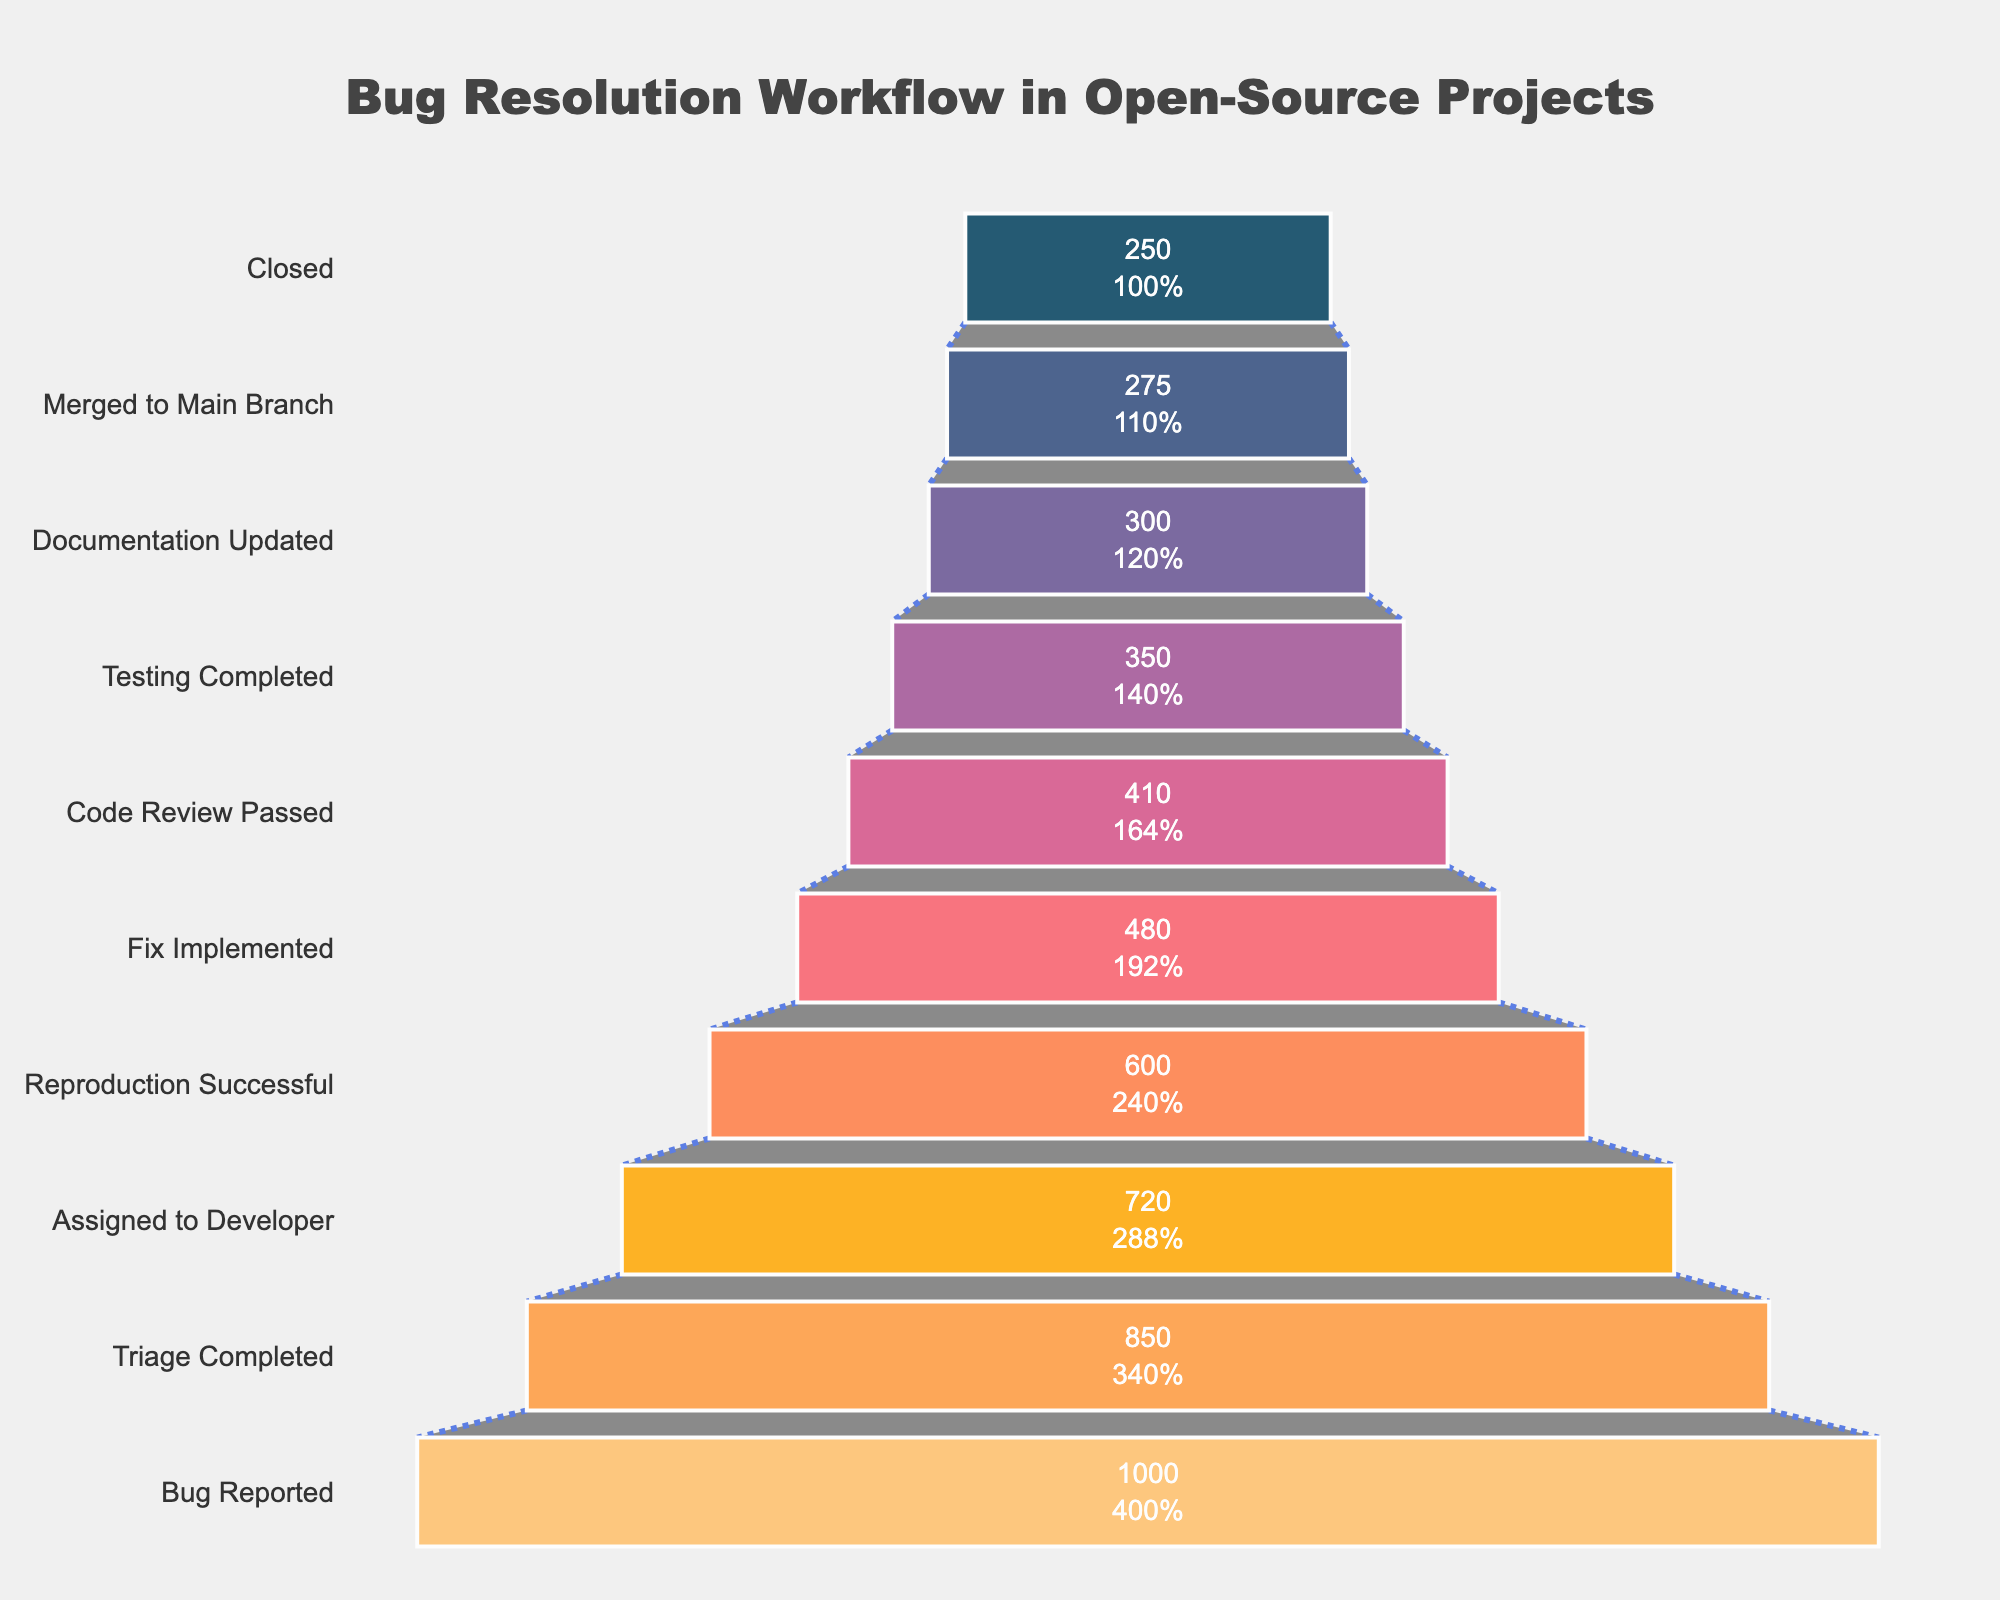What is the title of the figure? The title can be found above the funnel chart in a large, prominent font. By reading it, we can understand that it describes the process the chart is illustrating.
Answer: Bug Resolution Workflow in Open-Source Projects How many stages are there in the funnel chart? To find the number of stages, we need to count the distinct horizontal segments labeled on the y-axis of the chart.
Answer: 10 Which stage has the highest count? To determine the stage with the highest count, we look for the widest segment at the top part of the funnel, as this represents the largest value.
Answer: Bug Reported How many bugs were closed? The number of bugs closed can be identified by looking at the count associated with the "Closed" stage at the bottom of the funnel.
Answer: 250 What percentage of triaged bugs were successfully assigned to a developer? First, note the count of bugs at the "Triage Completed" stage and the "Assigned to Developer" stage. Then, calculate the percentage by dividing the latter by the former and multiplying by 100. 720 / 850 * 100 = 84.7%
Answer: 84.7% How many bugs successfully passed the code review? The number of bugs that passed code review can be seen by looking at the count for the "Code Review Passed" stage.
Answer: 410 What is the difference in bug counts between the "Documentation Updated" stage and the "Testing Completed" stage? Subtract the count for "Testing Completed" from the count for "Documentation Updated". 300 - 350 = -50
Answer: -50 How many more bugs passed reproduction than passed the assignment to a developer? Compare the counts for "Reproduction Successful" and "Assigned to Developer" stages. Subtract the smaller value from the larger value. 600 - 720 = -120
Answer: -120 Which stage has the lowest count? Identify the stage at the narrowest part of the funnel, which is located at its bottom, since it represents the stage with the fewest bugs.
Answer: Closed What percentage of reported bugs were merged to the main branch? First, get the count of "Merged to Main Branch" and "Bug Reported". Calculate the percentage by dividing the former by the latter and multiplying by 100. 275 / 1000 * 100 = 27.5%
Answer: 27.5% 